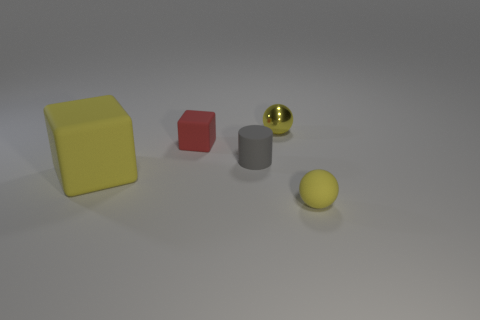Add 1 metal balls. How many objects exist? 6 Subtract all balls. How many objects are left? 3 Subtract 0 blue cubes. How many objects are left? 5 Subtract all large green things. Subtract all small rubber objects. How many objects are left? 2 Add 3 red rubber cubes. How many red rubber cubes are left? 4 Add 3 big purple metallic cylinders. How many big purple metallic cylinders exist? 3 